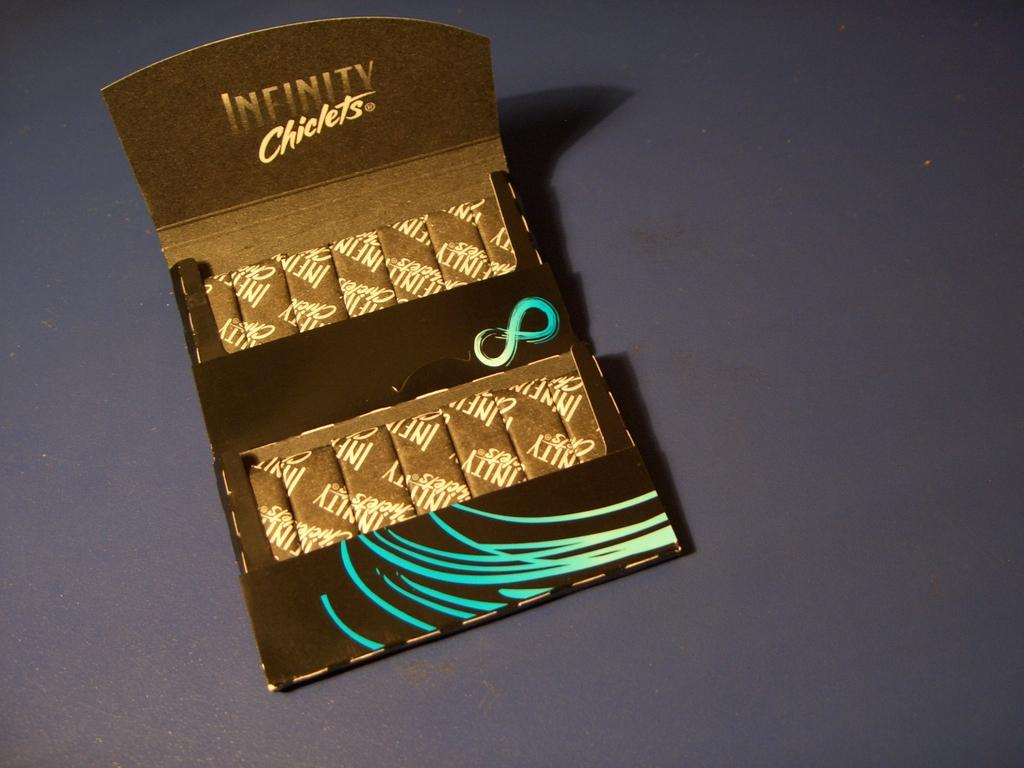<image>
Create a compact narrative representing the image presented. a black and aqua open box of Infinity Chiclets gum 